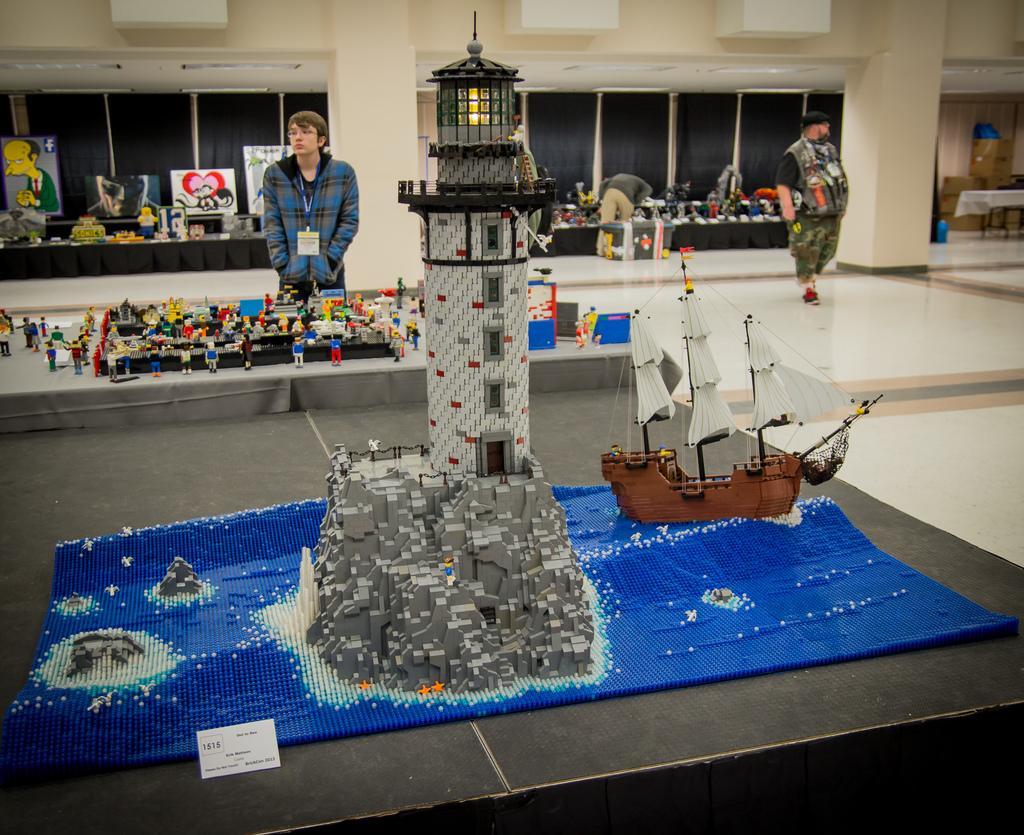Can you describe this image briefly? In this image we can see some objects placed here, we can see this person wearing blue color sweater and identity card is standing here. In the background, we can see a few more people, some objects, frames and windows. 